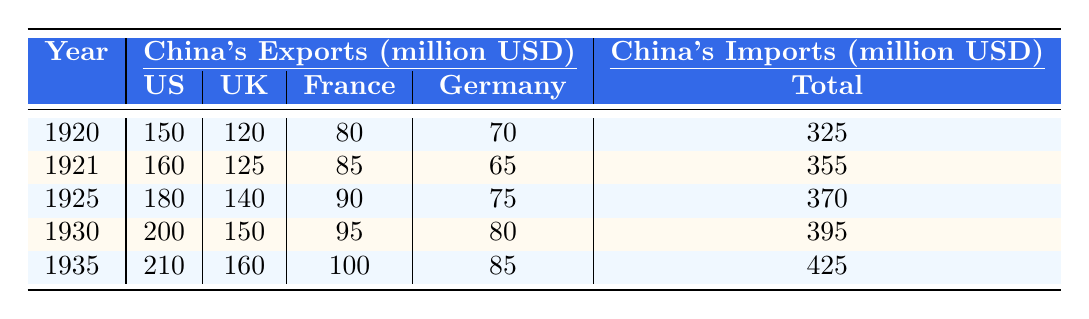What was the total export value of China to the United States in 1935? According to the table, China's exports to the United States in 1935 were 210 million USD.
Answer: 210 million USD What were China's exports to the United Kingdom in 1921? The table indicates that in 1921, China's exports to the United Kingdom were 125 million USD.
Answer: 125 million USD Which year saw the highest total exports to Western countries? By examining the total exports in each year, the highest total exports occurred in 1935 with 425 million USD.
Answer: 1935 What were the imports from Germany in 1930? The table shows that China's imports from Germany in 1930 were 70 million USD.
Answer: 70 million USD What was the difference in total exports between 1920 and 1925? The total exports in 1920 were 325 million USD, while in 1925 it was 370 million USD. The difference is 370 - 325 = 45 million USD.
Answer: 45 million USD In which year did exports to France first exceed 90 million USD? Looking at the exports to France across the years, they first exceeded 90 million USD in 1925, when it reached 90 million USD.
Answer: 1925 What was the average export value to Western countries over the years 1920 to 1935? The total exports from 1920 (325 million USD), 1921 (355 million USD), 1925 (370 million USD), 1930 (395 million USD), and 1935 (425 million USD) add up to 1800 million USD. Dividing this by the 5 years gives an average of 1800 / 5 = 360 million USD.
Answer: 360 million USD Did China's imports from the United Kingdom increase every year from 1920 to 1935? By checking each year's imports from the United Kingdom, we find that they were 90 million USD in 1920, 95 million USD in 1921, 100 million USD in 1925, 105 million USD in 1930, and 115 million USD in 1935, which shows an increase every year.
Answer: Yes What was the total value of China's imports from Western countries in 1935? Referring to the table, total imports in 1935 are calculated as follows: 140 (US) + 115 (UK) + 95 (France) + 75 (Germany) = 425 million USD.
Answer: 425 million USD Which Western country had the lowest export value from China in 1921? The export values in 1921 were 160 million USD (US), 125 million USD (UK), 85 million USD (France), and 65 million USD (Germany). Germany had the lowest export value at 65 million USD.
Answer: Germany 